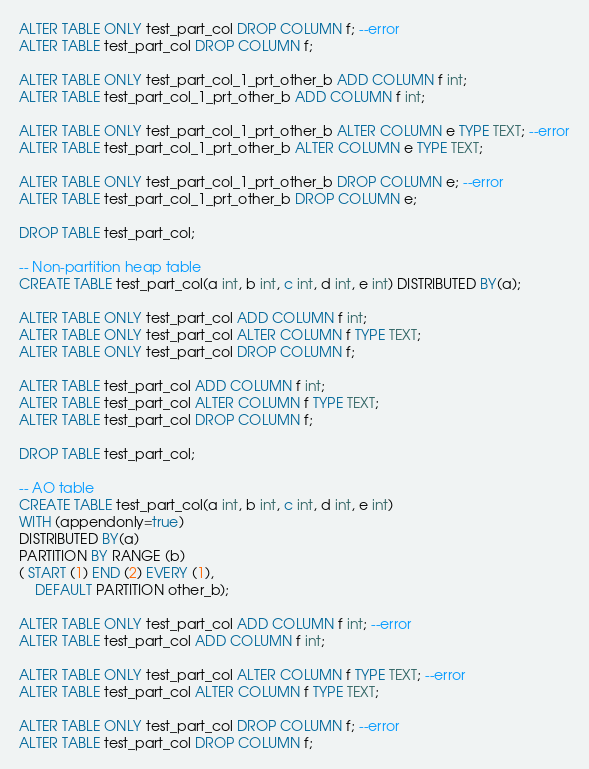<code> <loc_0><loc_0><loc_500><loc_500><_SQL_>
ALTER TABLE ONLY test_part_col DROP COLUMN f; --error
ALTER TABLE test_part_col DROP COLUMN f;

ALTER TABLE ONLY test_part_col_1_prt_other_b ADD COLUMN f int;
ALTER TABLE test_part_col_1_prt_other_b ADD COLUMN f int;

ALTER TABLE ONLY test_part_col_1_prt_other_b ALTER COLUMN e TYPE TEXT; --error
ALTER TABLE test_part_col_1_prt_other_b ALTER COLUMN e TYPE TEXT;

ALTER TABLE ONLY test_part_col_1_prt_other_b DROP COLUMN e; --error
ALTER TABLE test_part_col_1_prt_other_b DROP COLUMN e;

DROP TABLE test_part_col;

-- Non-partition heap table
CREATE TABLE test_part_col(a int, b int, c int, d int, e int) DISTRIBUTED BY(a);

ALTER TABLE ONLY test_part_col ADD COLUMN f int;
ALTER TABLE ONLY test_part_col ALTER COLUMN f TYPE TEXT;
ALTER TABLE ONLY test_part_col DROP COLUMN f;

ALTER TABLE test_part_col ADD COLUMN f int;
ALTER TABLE test_part_col ALTER COLUMN f TYPE TEXT;
ALTER TABLE test_part_col DROP COLUMN f;

DROP TABLE test_part_col;

-- AO table
CREATE TABLE test_part_col(a int, b int, c int, d int, e int)
WITH (appendonly=true)
DISTRIBUTED BY(a)
PARTITION BY RANGE (b)
( START (1) END (2) EVERY (1),
    DEFAULT PARTITION other_b);

ALTER TABLE ONLY test_part_col ADD COLUMN f int; --error
ALTER TABLE test_part_col ADD COLUMN f int;

ALTER TABLE ONLY test_part_col ALTER COLUMN f TYPE TEXT; --error
ALTER TABLE test_part_col ALTER COLUMN f TYPE TEXT;

ALTER TABLE ONLY test_part_col DROP COLUMN f; --error
ALTER TABLE test_part_col DROP COLUMN f;
</code> 